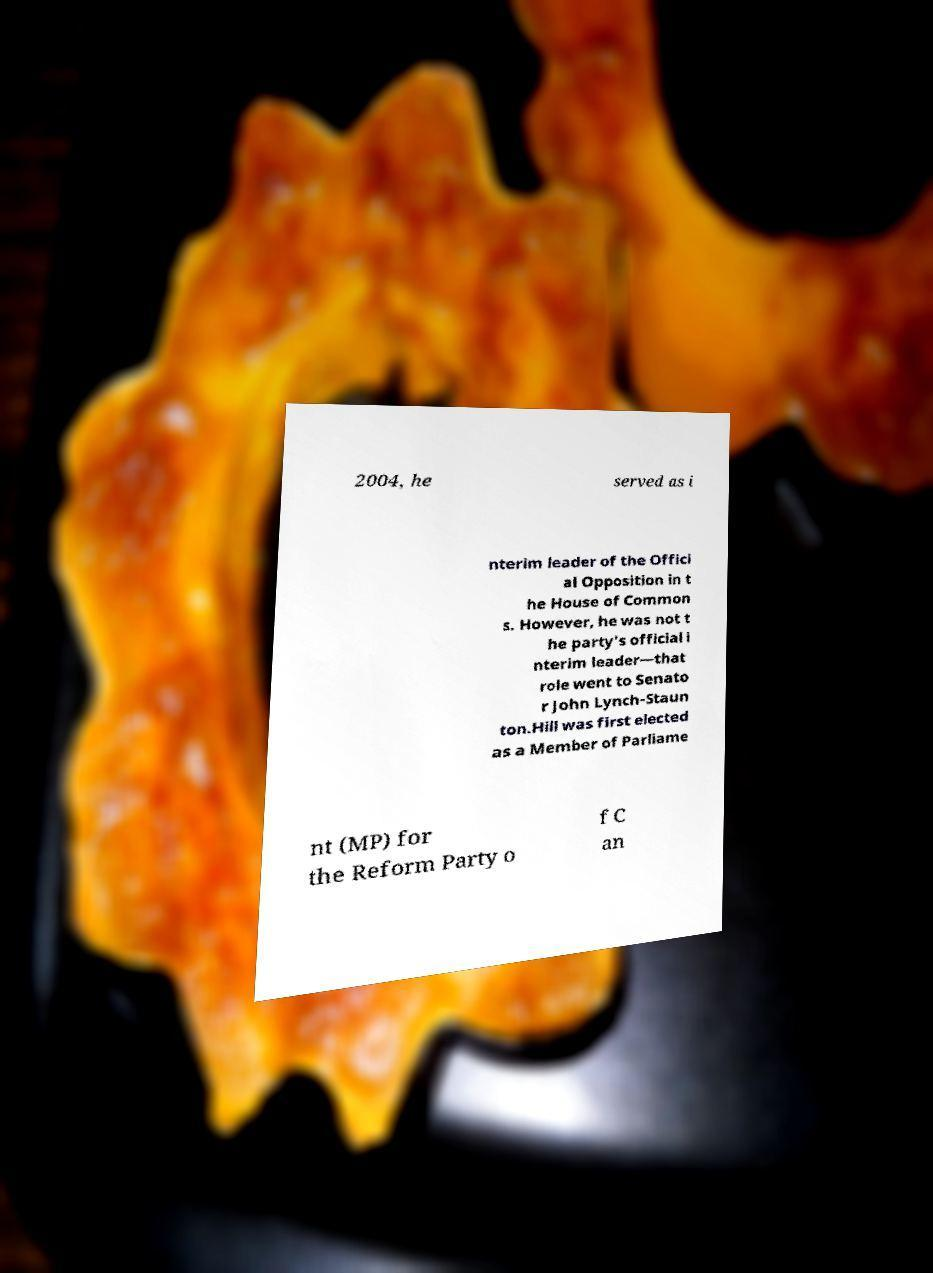What messages or text are displayed in this image? I need them in a readable, typed format. 2004, he served as i nterim leader of the Offici al Opposition in t he House of Common s. However, he was not t he party's official i nterim leader—that role went to Senato r John Lynch-Staun ton.Hill was first elected as a Member of Parliame nt (MP) for the Reform Party o f C an 